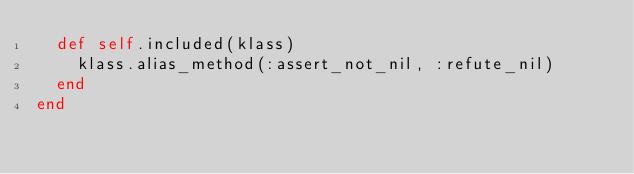Convert code to text. <code><loc_0><loc_0><loc_500><loc_500><_Ruby_>  def self.included(klass)
    klass.alias_method(:assert_not_nil, :refute_nil)
  end
end
</code> 